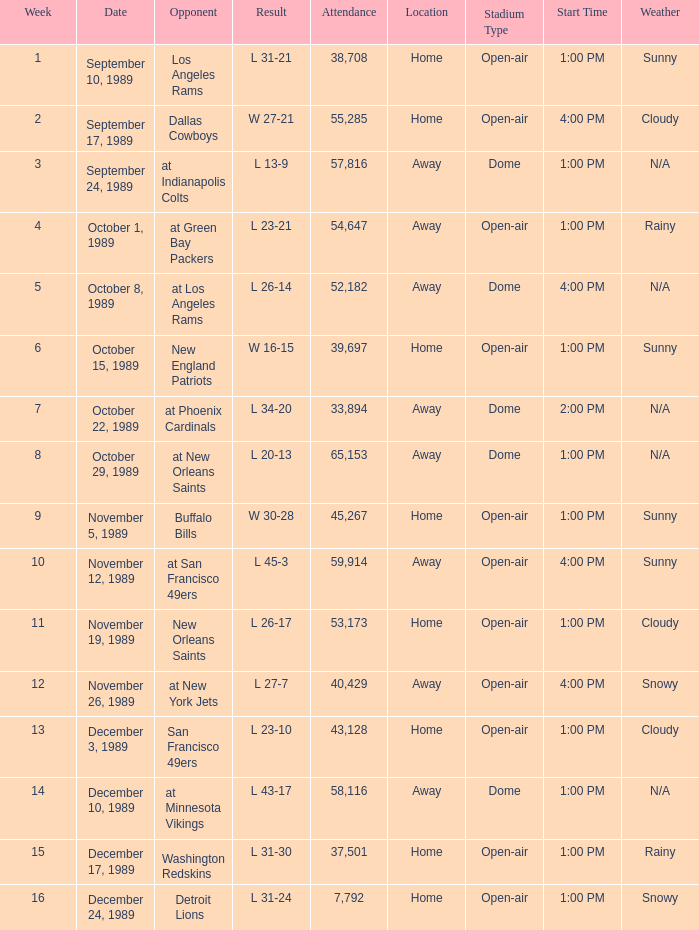When was the week with an attendance of 40,429? 12.0. 